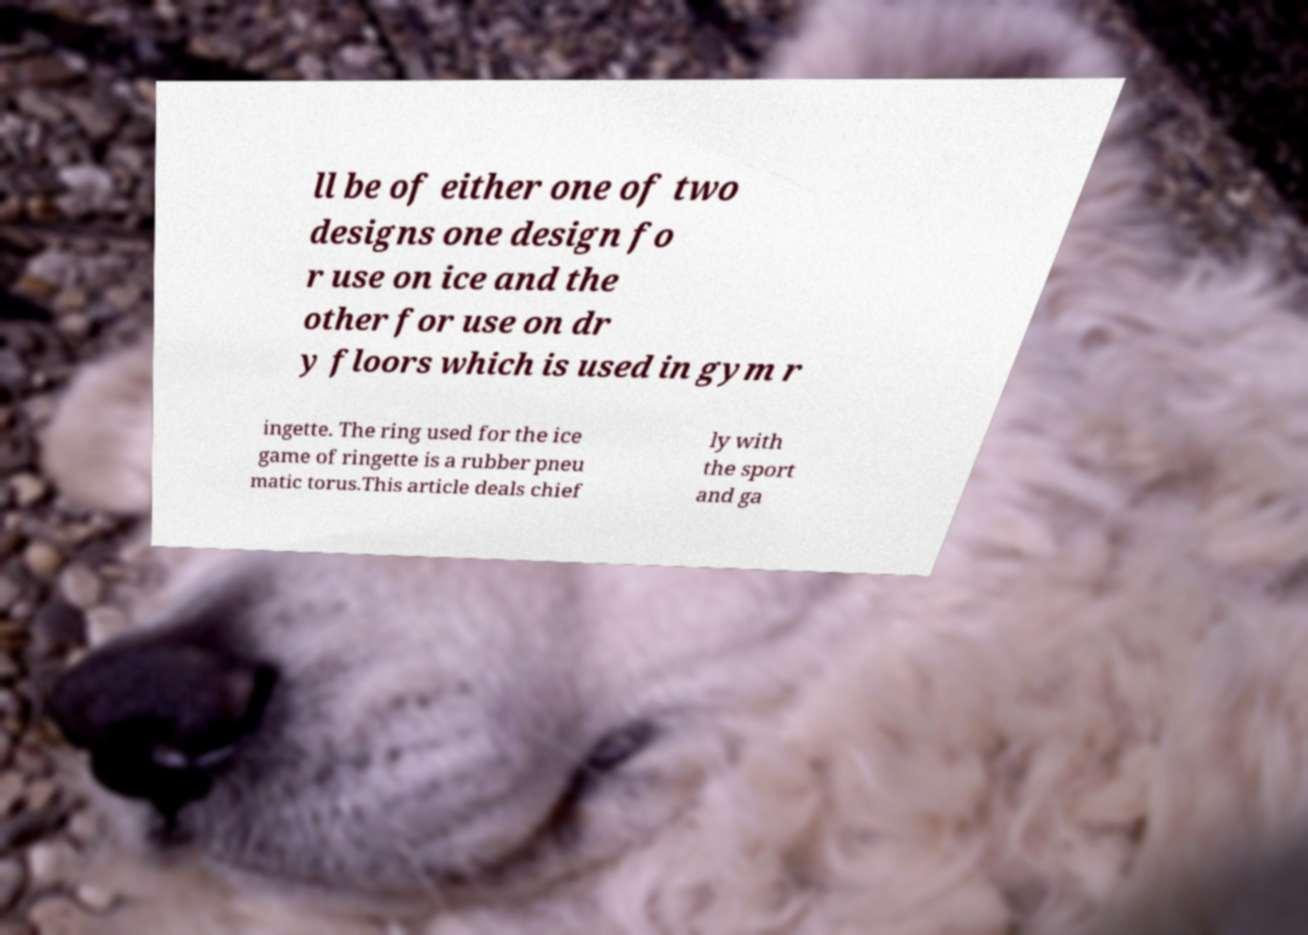I need the written content from this picture converted into text. Can you do that? ll be of either one of two designs one design fo r use on ice and the other for use on dr y floors which is used in gym r ingette. The ring used for the ice game of ringette is a rubber pneu matic torus.This article deals chief ly with the sport and ga 